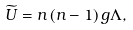Convert formula to latex. <formula><loc_0><loc_0><loc_500><loc_500>\widetilde { U } = n \left ( n - 1 \right ) g \Lambda ,</formula> 